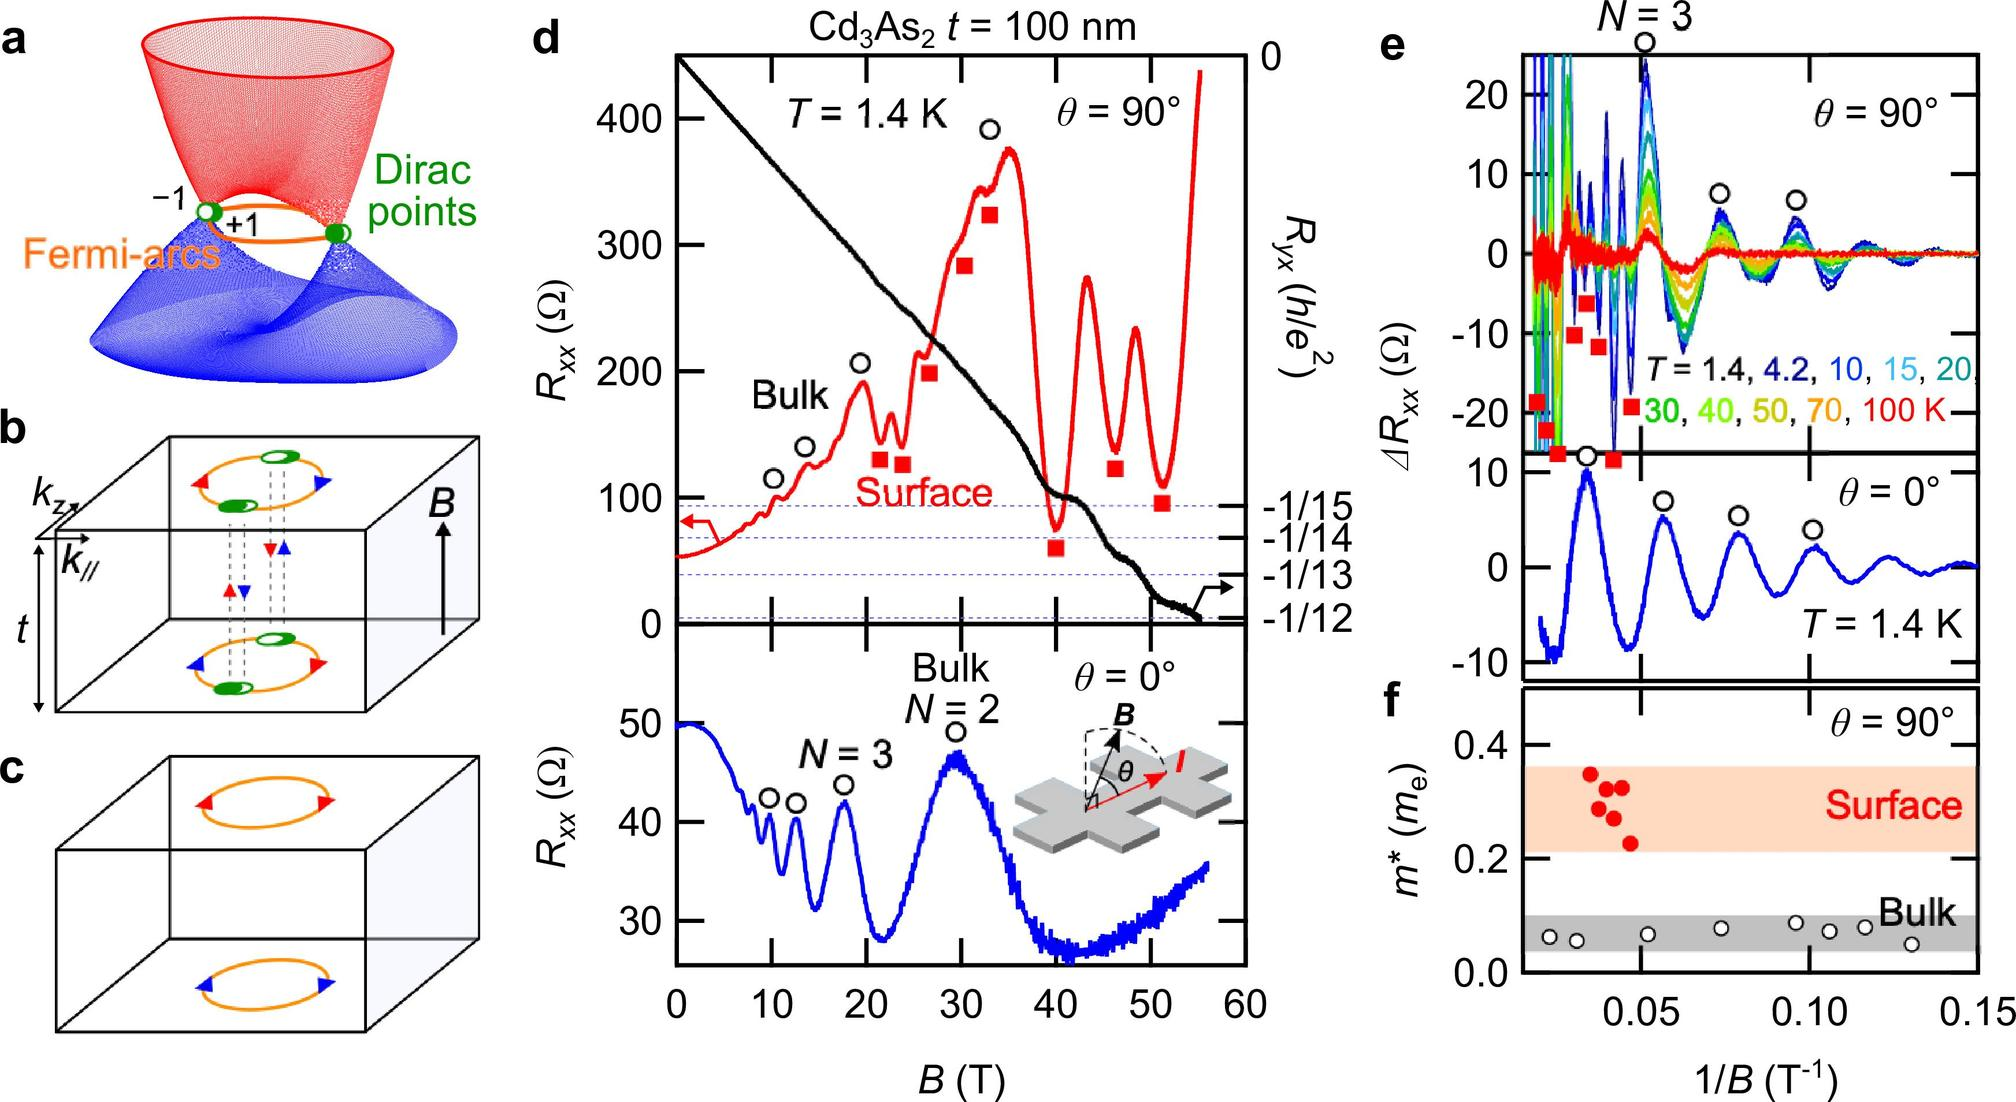Based on panel f, what is the relationship between the effective mass \( m^* \) and the inverse of magnetic field strength \( 1/B \) for the surface states? \( m^* \) increases linearly with \( 1/B \) \( m^* \) decreases with increasing \( 1/B \) \( m^* \) shows no significant change with variations in \( 1/B \) \( m^* \) has a parabolic relationship with \( 1/B \) In panel f, the plot for the surface states (shown in red) remains relatively flat as \( 1/B \) changes, indicating that the effective mass \( m^* \) shows no significant change with variations in \( 1/B \). Therefore, the correct answer is C. 